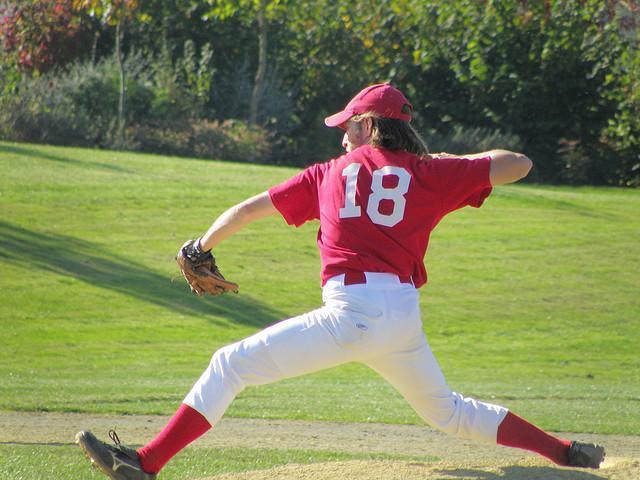How many bus on the road?
Give a very brief answer. 0. 